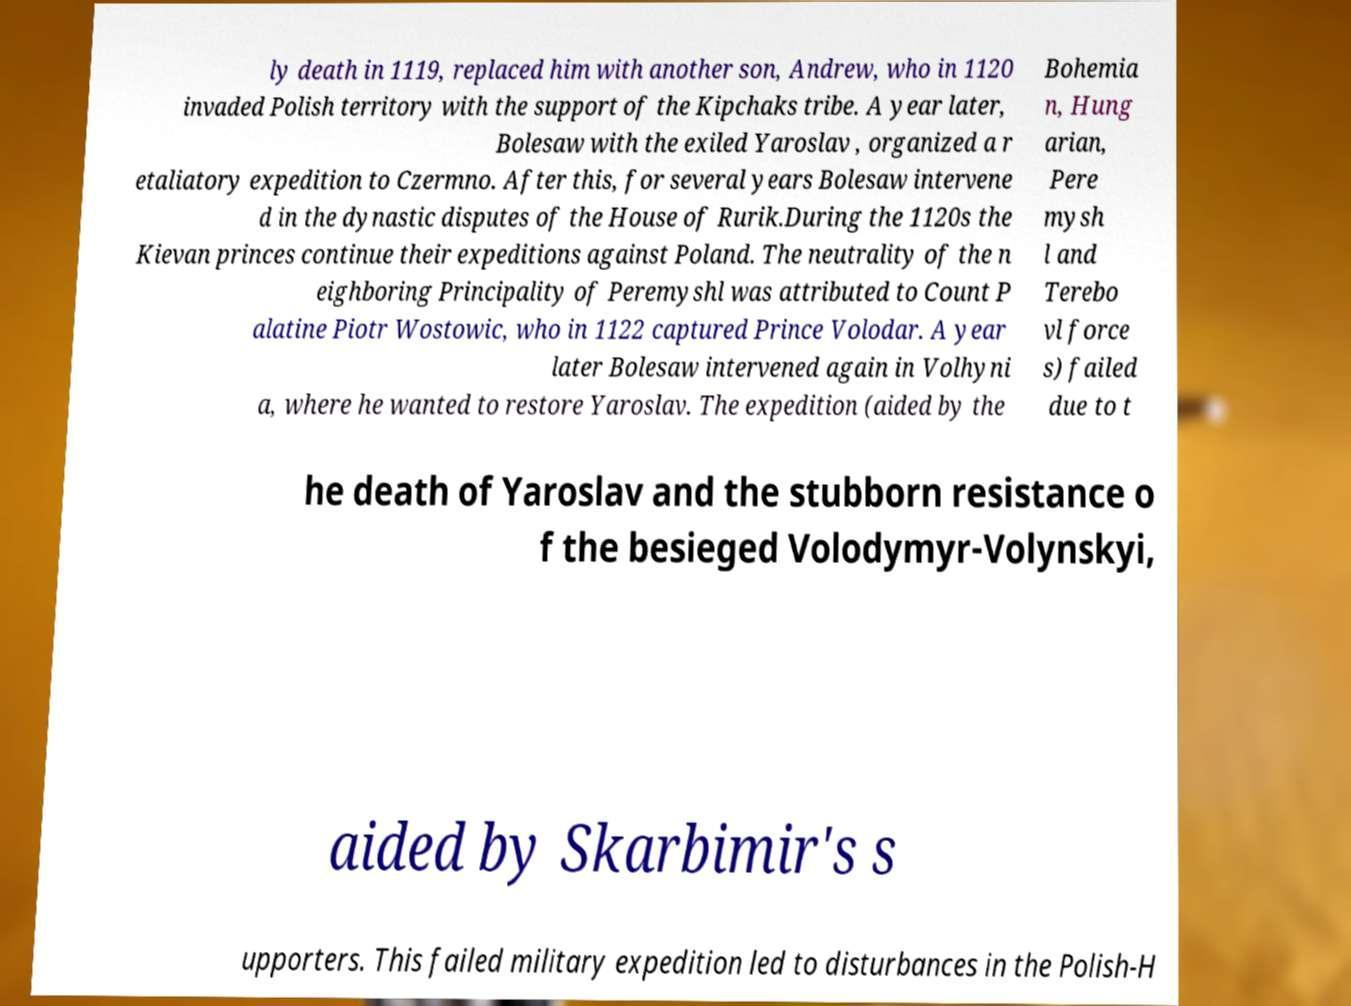Please identify and transcribe the text found in this image. ly death in 1119, replaced him with another son, Andrew, who in 1120 invaded Polish territory with the support of the Kipchaks tribe. A year later, Bolesaw with the exiled Yaroslav , organized a r etaliatory expedition to Czermno. After this, for several years Bolesaw intervene d in the dynastic disputes of the House of Rurik.During the 1120s the Kievan princes continue their expeditions against Poland. The neutrality of the n eighboring Principality of Peremyshl was attributed to Count P alatine Piotr Wostowic, who in 1122 captured Prince Volodar. A year later Bolesaw intervened again in Volhyni a, where he wanted to restore Yaroslav. The expedition (aided by the Bohemia n, Hung arian, Pere mysh l and Terebo vl force s) failed due to t he death of Yaroslav and the stubborn resistance o f the besieged Volodymyr-Volynskyi, aided by Skarbimir's s upporters. This failed military expedition led to disturbances in the Polish-H 